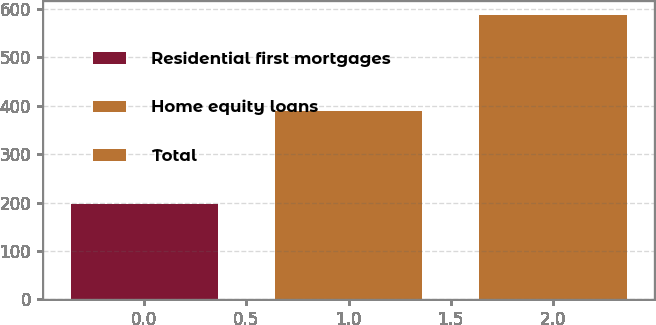Convert chart to OTSL. <chart><loc_0><loc_0><loc_500><loc_500><bar_chart><fcel>Residential first mortgages<fcel>Home equity loans<fcel>Total<nl><fcel>197<fcel>390<fcel>587<nl></chart> 